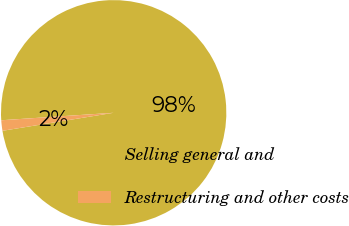Convert chart. <chart><loc_0><loc_0><loc_500><loc_500><pie_chart><fcel>Selling general and<fcel>Restructuring and other costs<nl><fcel>98.5%<fcel>1.5%<nl></chart> 